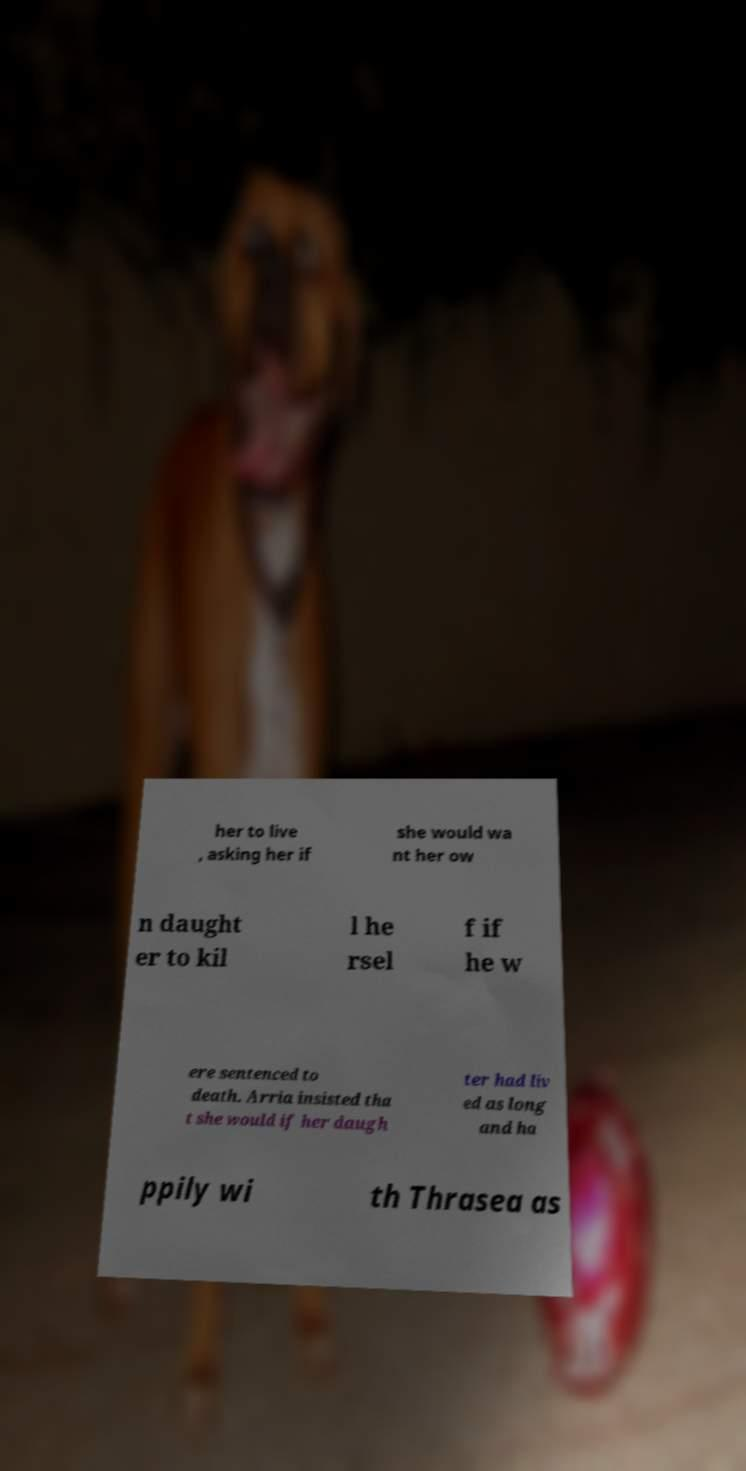Can you accurately transcribe the text from the provided image for me? her to live , asking her if she would wa nt her ow n daught er to kil l he rsel f if he w ere sentenced to death. Arria insisted tha t she would if her daugh ter had liv ed as long and ha ppily wi th Thrasea as 